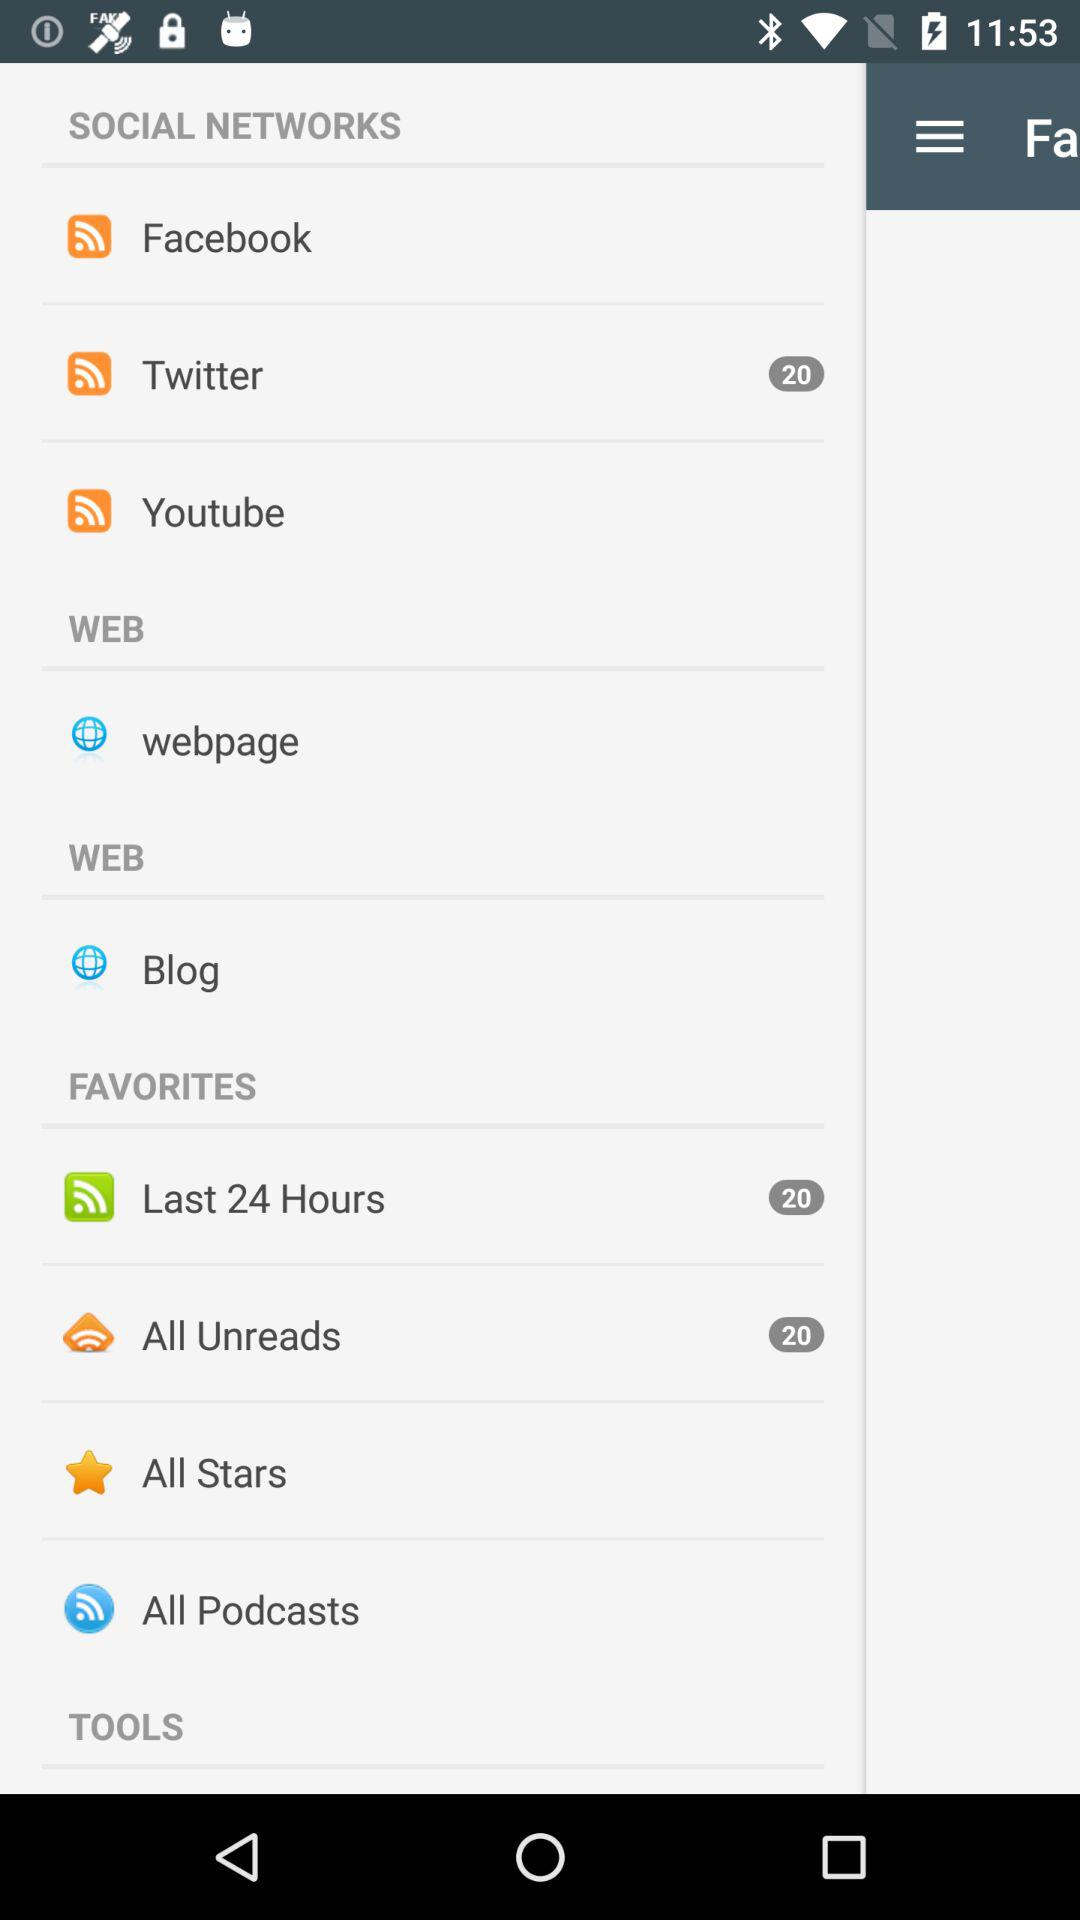What is the total number of "All Unreads"? The total number is 20. 